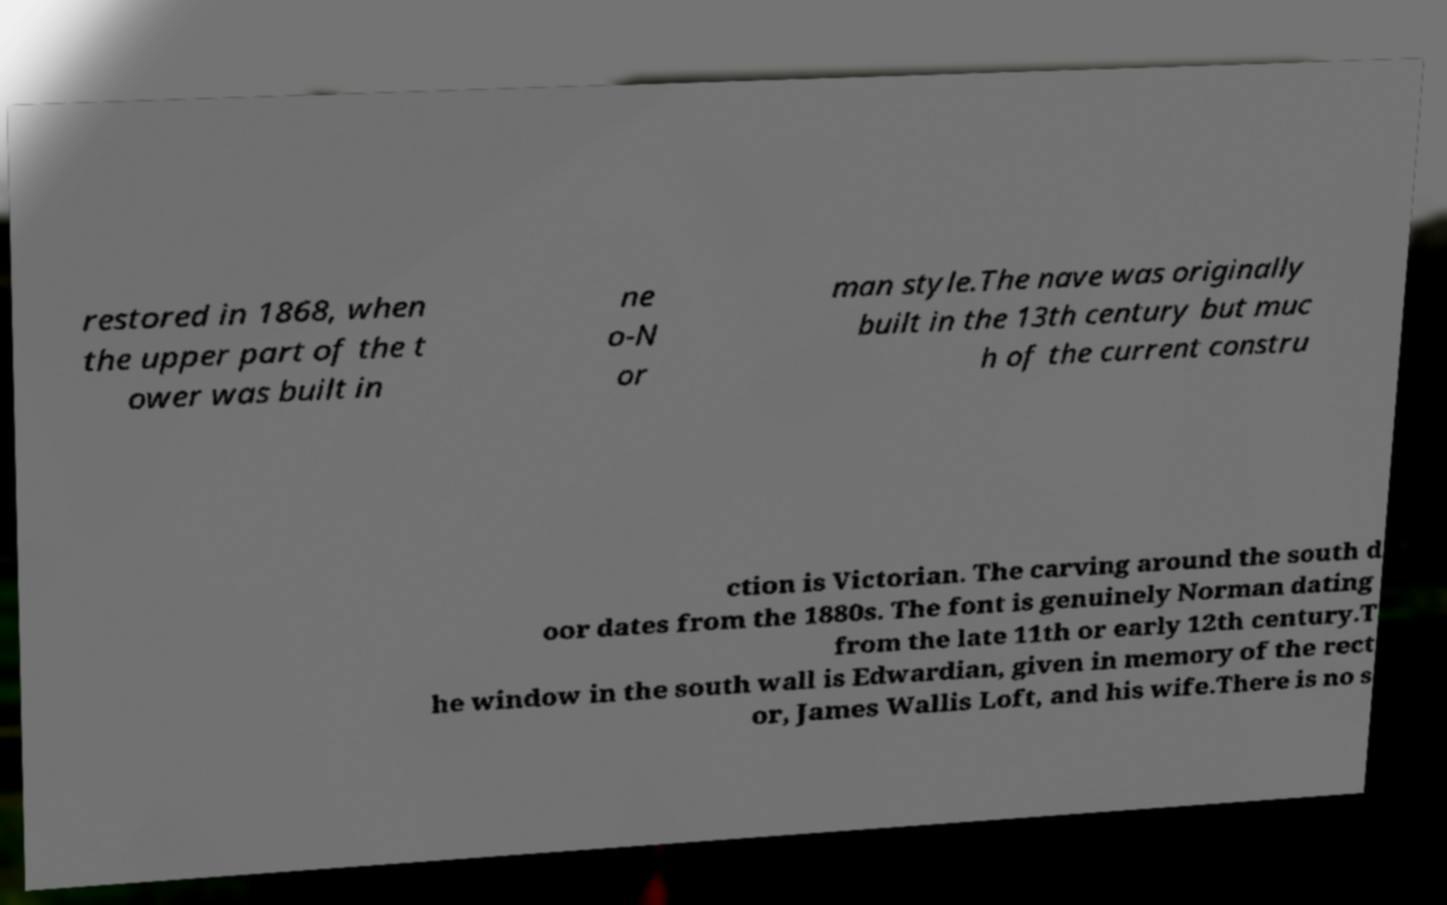What messages or text are displayed in this image? I need them in a readable, typed format. restored in 1868, when the upper part of the t ower was built in ne o-N or man style.The nave was originally built in the 13th century but muc h of the current constru ction is Victorian. The carving around the south d oor dates from the 1880s. The font is genuinely Norman dating from the late 11th or early 12th century.T he window in the south wall is Edwardian, given in memory of the rect or, James Wallis Loft, and his wife.There is no s 